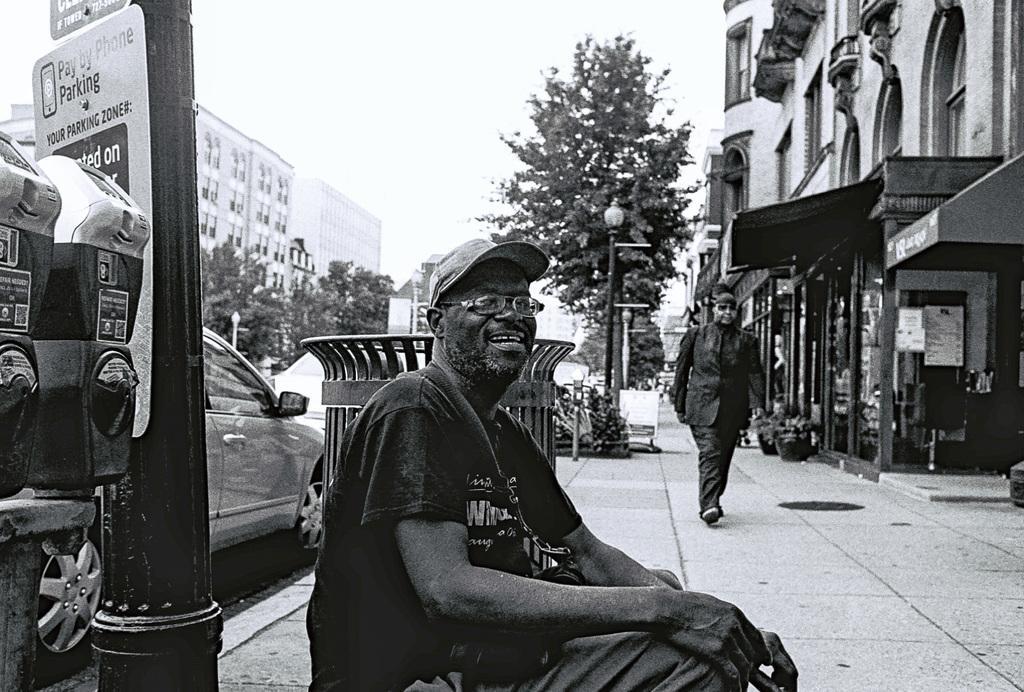In one or two sentences, can you explain what this image depicts? In this picture I can see there is a man sitting on the floor and in the backdrop I can see there is a man walking here on the walk way and there are few buildings and trees and the sky is clear. 